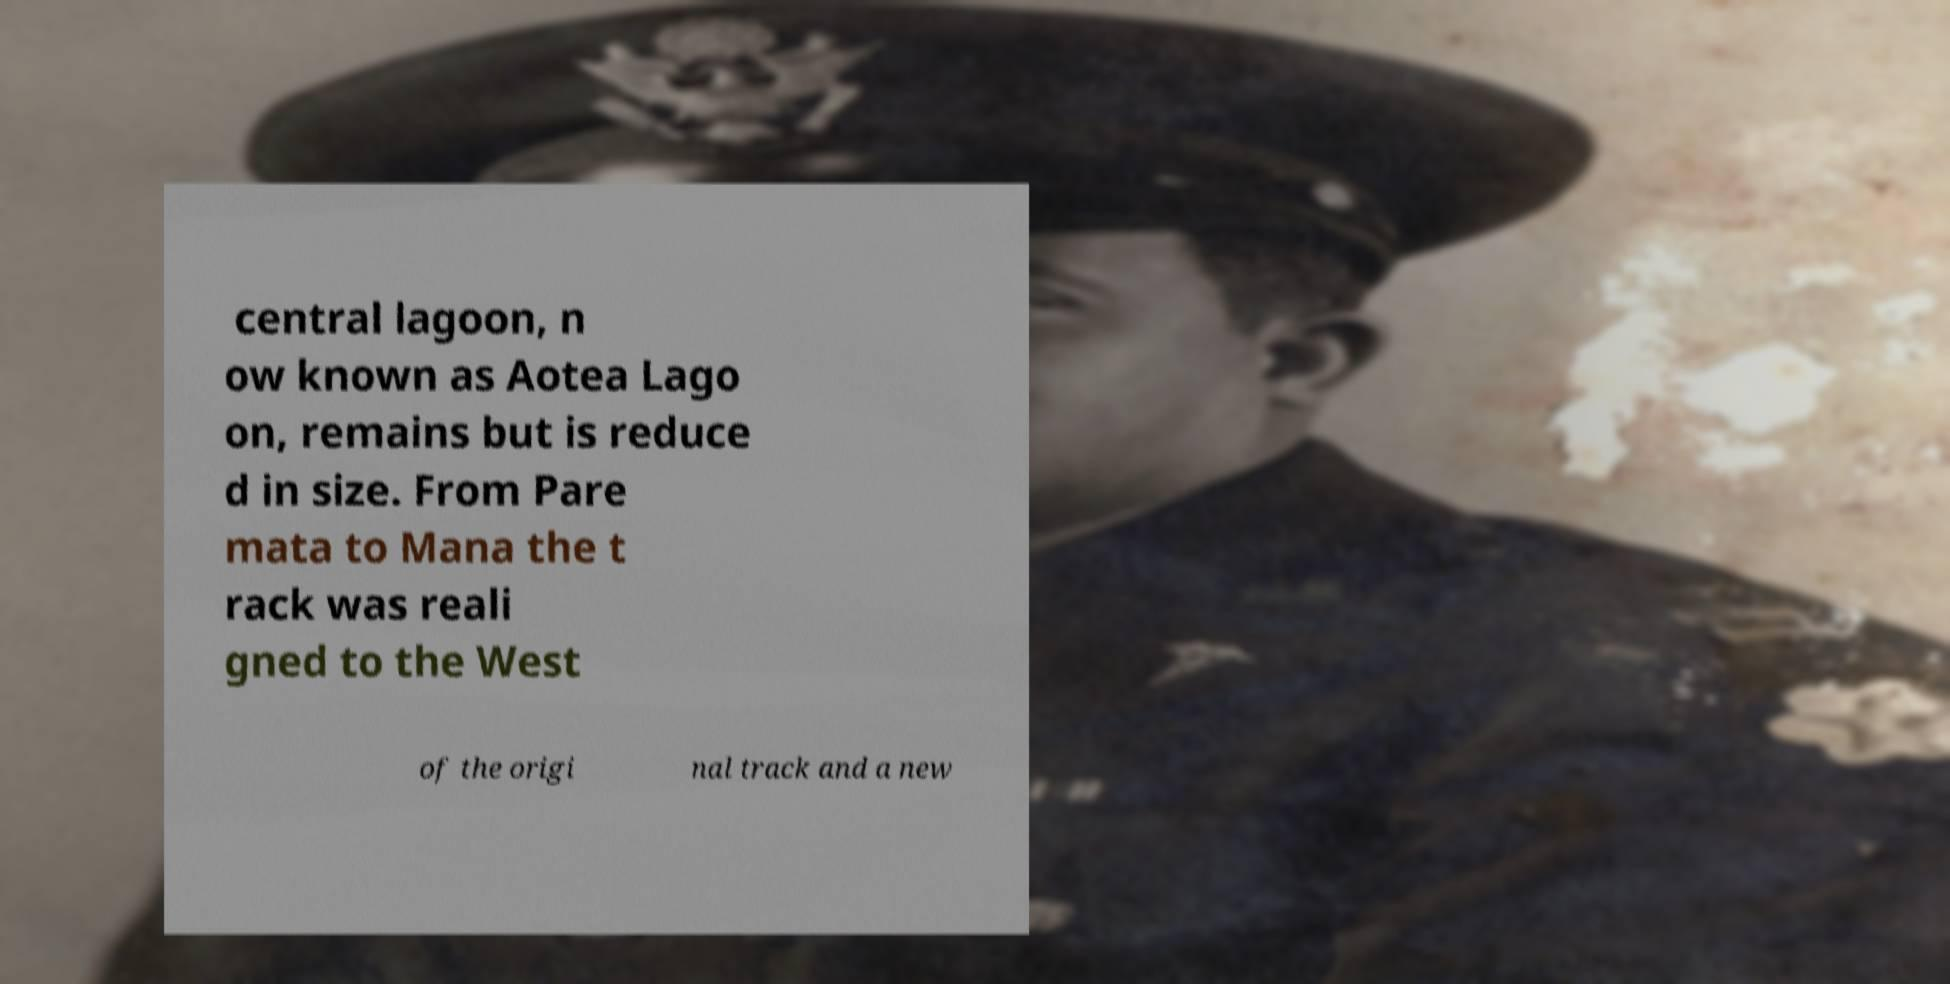What messages or text are displayed in this image? I need them in a readable, typed format. central lagoon, n ow known as Aotea Lago on, remains but is reduce d in size. From Pare mata to Mana the t rack was reali gned to the West of the origi nal track and a new 